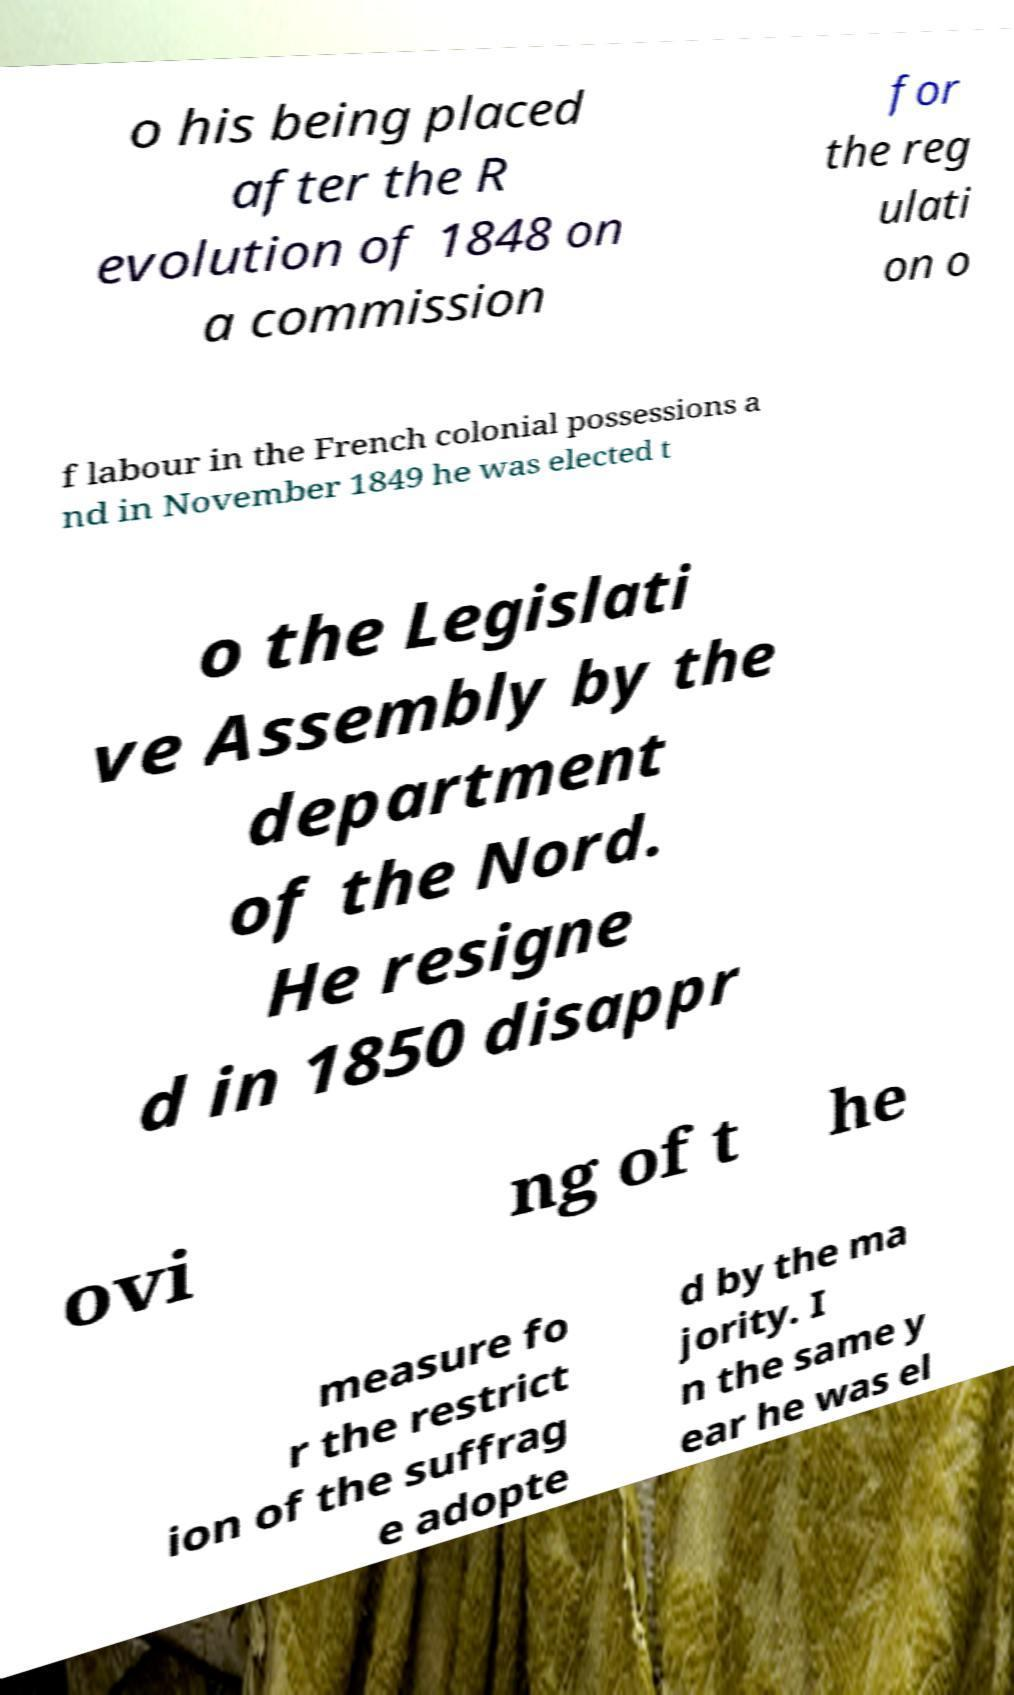There's text embedded in this image that I need extracted. Can you transcribe it verbatim? o his being placed after the R evolution of 1848 on a commission for the reg ulati on o f labour in the French colonial possessions a nd in November 1849 he was elected t o the Legislati ve Assembly by the department of the Nord. He resigne d in 1850 disappr ovi ng of t he measure fo r the restrict ion of the suffrag e adopte d by the ma jority. I n the same y ear he was el 